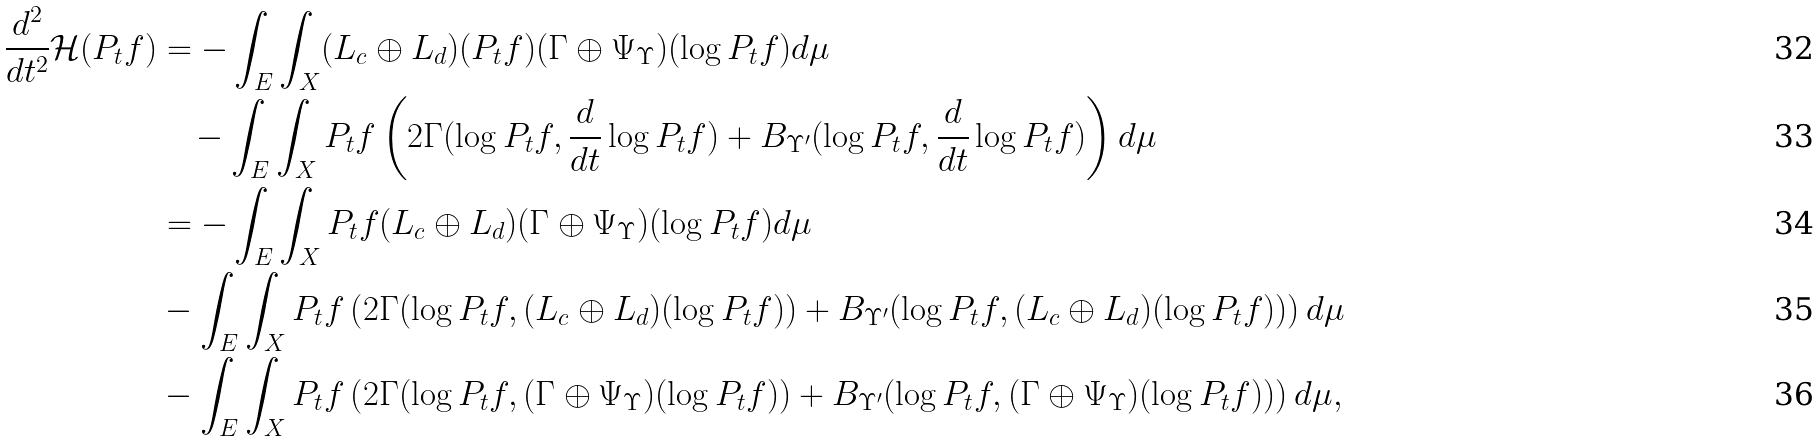<formula> <loc_0><loc_0><loc_500><loc_500>\frac { d ^ { 2 } } { d t ^ { 2 } } \mathcal { H } ( P _ { t } f ) & = - \int _ { E } \int _ { X } ( L _ { c } \oplus L _ { d } ) ( P _ { t } f ) ( \Gamma \oplus \Psi _ { \Upsilon } ) ( \log P _ { t } f ) d \mu \\ & \quad - \int _ { E } \int _ { X } P _ { t } f \left ( 2 \Gamma ( \log P _ { t } f , \frac { d } { d t } \log P _ { t } f ) + B _ { \Upsilon ^ { \prime } } ( \log P _ { t } f , \frac { d } { d t } \log P _ { t } f ) \right ) d \mu \\ & = - \int _ { E } \int _ { X } P _ { t } f ( L _ { c } \oplus L _ { d } ) ( \Gamma \oplus \Psi _ { \Upsilon } ) ( \log P _ { t } f ) d \mu \\ & - \int _ { E } \int _ { X } P _ { t } f \left ( 2 \Gamma ( \log P _ { t } f , ( L _ { c } \oplus L _ { d } ) ( \log P _ { t } f ) ) + B _ { \Upsilon ^ { \prime } } ( \log P _ { t } f , ( L _ { c } \oplus L _ { d } ) ( \log P _ { t } f ) ) \right ) d \mu \\ & - \int _ { E } \int _ { X } P _ { t } f \left ( 2 \Gamma ( \log P _ { t } f , ( \Gamma \oplus \Psi _ { \Upsilon } ) ( \log P _ { t } f ) ) + B _ { \Upsilon ^ { \prime } } ( \log P _ { t } f , ( \Gamma \oplus \Psi _ { \Upsilon } ) ( \log P _ { t } f ) ) \right ) d \mu ,</formula> 